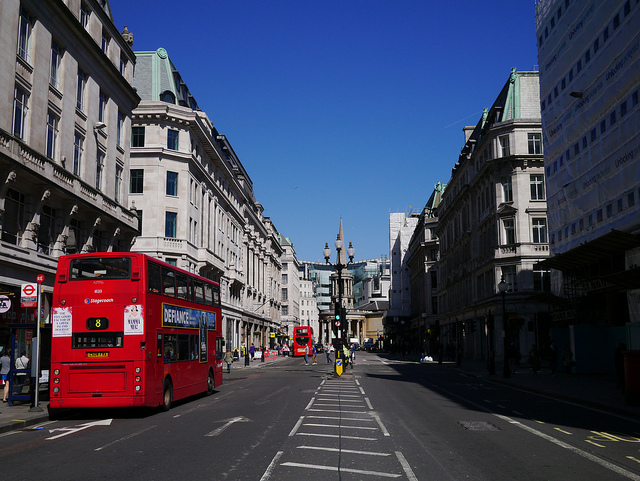What clues in the image suggest the location of this street scene? Several clues point to the location of this street scene. First and foremost, the red double-decker buses are iconic to London, England. The architecture of the buildings, with their grandeur and style, also indicates a European, specifically British, city. Additionally, the clear blue sky and the particular design of the street signs can further point towards this being a scene from London on a sunny day.  What time of day do you think it is, based on the shadows and lighting in the photo? Analyzing the length and direction of the shadows cast by the buses, bicycles, and street fixtures, it seems that the photo was taken in mid to late morning. The shadows are present but not overly long, which indicates the sun is not at its zenith but has been up for a few hours, likely suggesting a time between 9 am and 11 am. 